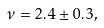Convert formula to latex. <formula><loc_0><loc_0><loc_500><loc_500>\nu = 2 . 4 \pm 0 . 3 ,</formula> 